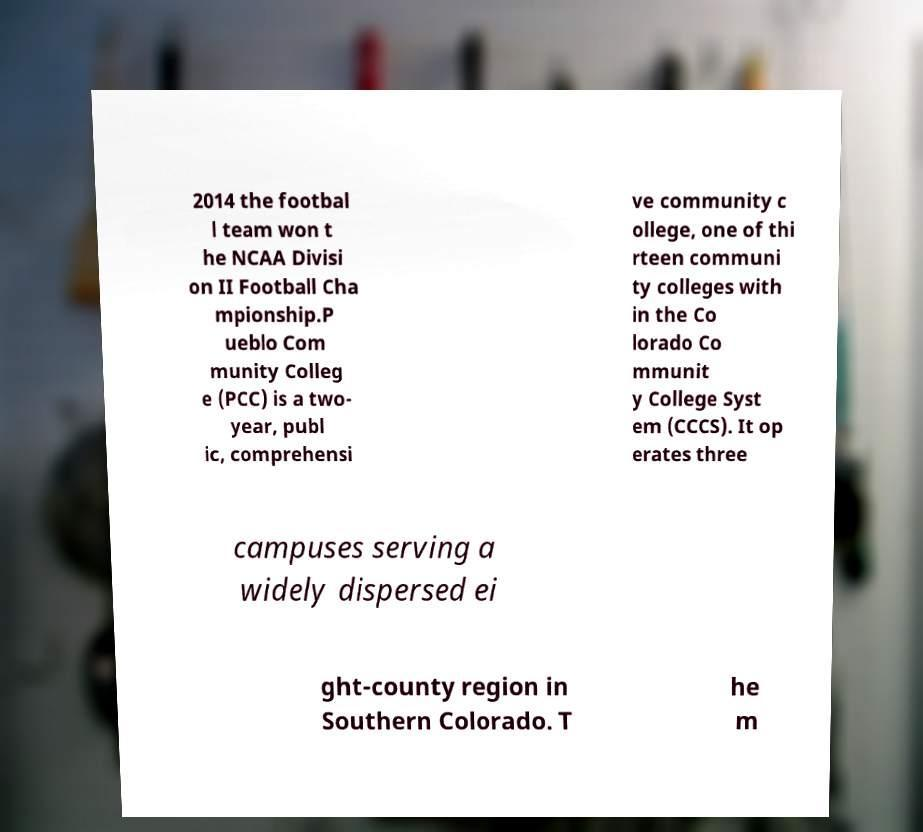For documentation purposes, I need the text within this image transcribed. Could you provide that? 2014 the footbal l team won t he NCAA Divisi on II Football Cha mpionship.P ueblo Com munity Colleg e (PCC) is a two- year, publ ic, comprehensi ve community c ollege, one of thi rteen communi ty colleges with in the Co lorado Co mmunit y College Syst em (CCCS). It op erates three campuses serving a widely dispersed ei ght-county region in Southern Colorado. T he m 